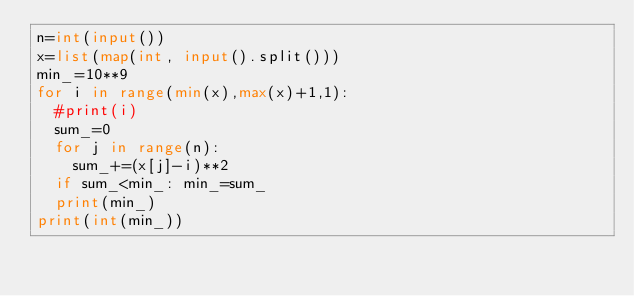<code> <loc_0><loc_0><loc_500><loc_500><_Python_>n=int(input())
x=list(map(int, input().split()))
min_=10**9
for i in range(min(x),max(x)+1,1):
  #print(i)
  sum_=0
  for j in range(n):
    sum_+=(x[j]-i)**2
  if sum_<min_: min_=sum_
  print(min_)
print(int(min_))</code> 